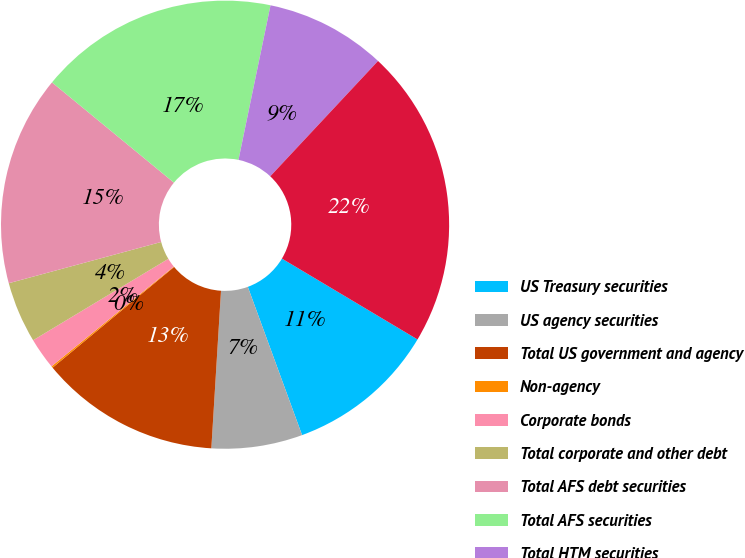<chart> <loc_0><loc_0><loc_500><loc_500><pie_chart><fcel>US Treasury securities<fcel>US agency securities<fcel>Total US government and agency<fcel>Non-agency<fcel>Corporate bonds<fcel>Total corporate and other debt<fcel>Total AFS debt securities<fcel>Total AFS securities<fcel>Total HTM securities<fcel>Total investment securities<nl><fcel>10.86%<fcel>6.56%<fcel>13.01%<fcel>0.12%<fcel>2.27%<fcel>4.42%<fcel>15.16%<fcel>17.3%<fcel>8.71%<fcel>21.6%<nl></chart> 